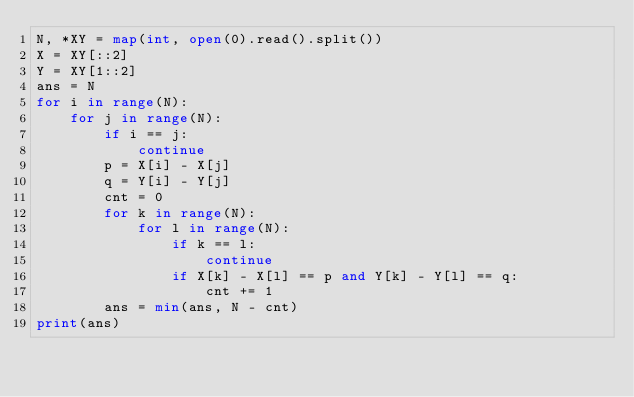Convert code to text. <code><loc_0><loc_0><loc_500><loc_500><_Python_>N, *XY = map(int, open(0).read().split())
X = XY[::2]
Y = XY[1::2]
ans = N
for i in range(N):
    for j in range(N):
        if i == j:
            continue
        p = X[i] - X[j]
        q = Y[i] - Y[j]
        cnt = 0
        for k in range(N):
            for l in range(N):
                if k == l:
                    continue
                if X[k] - X[l] == p and Y[k] - Y[l] == q:
                    cnt += 1
        ans = min(ans, N - cnt)
print(ans)
</code> 